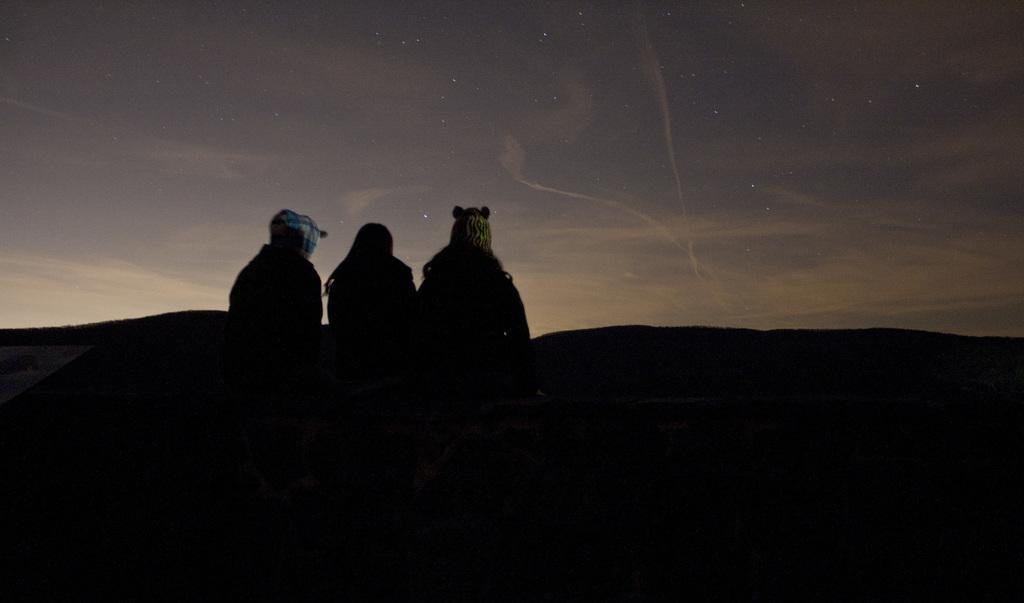How would you summarize this image in a sentence or two? In the middle of the image three persons are sitting. Behind them there is sky and clouds and stars. 